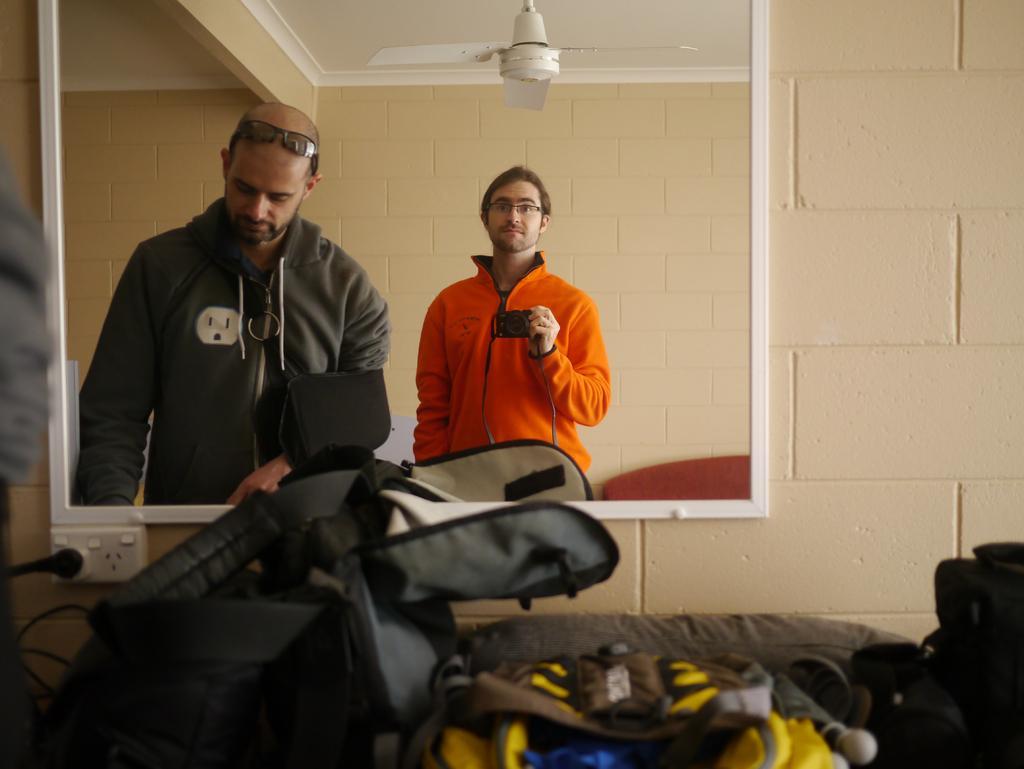Could you give a brief overview of what you see in this image? We can see bags and switch board and we can see mirror on a wall,in this mirror we can see two people standing and this person holding a camera,at the top we can see fan. 